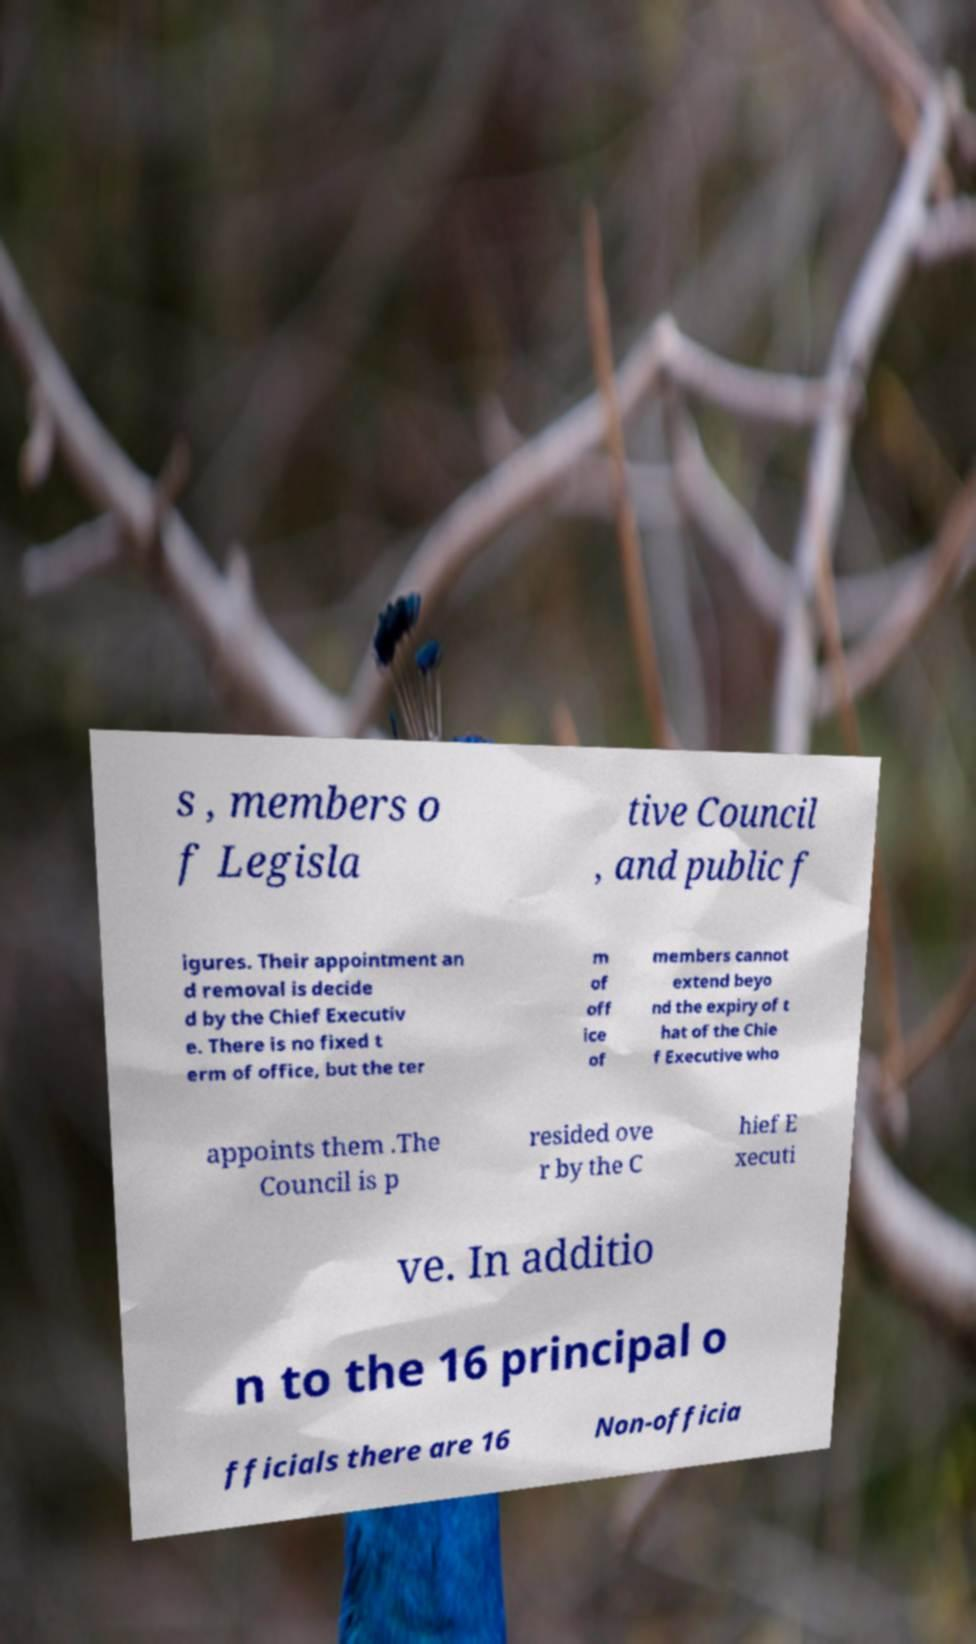What messages or text are displayed in this image? I need them in a readable, typed format. s , members o f Legisla tive Council , and public f igures. Their appointment an d removal is decide d by the Chief Executiv e. There is no fixed t erm of office, but the ter m of off ice of members cannot extend beyo nd the expiry of t hat of the Chie f Executive who appoints them .The Council is p resided ove r by the C hief E xecuti ve. In additio n to the 16 principal o fficials there are 16 Non-officia 